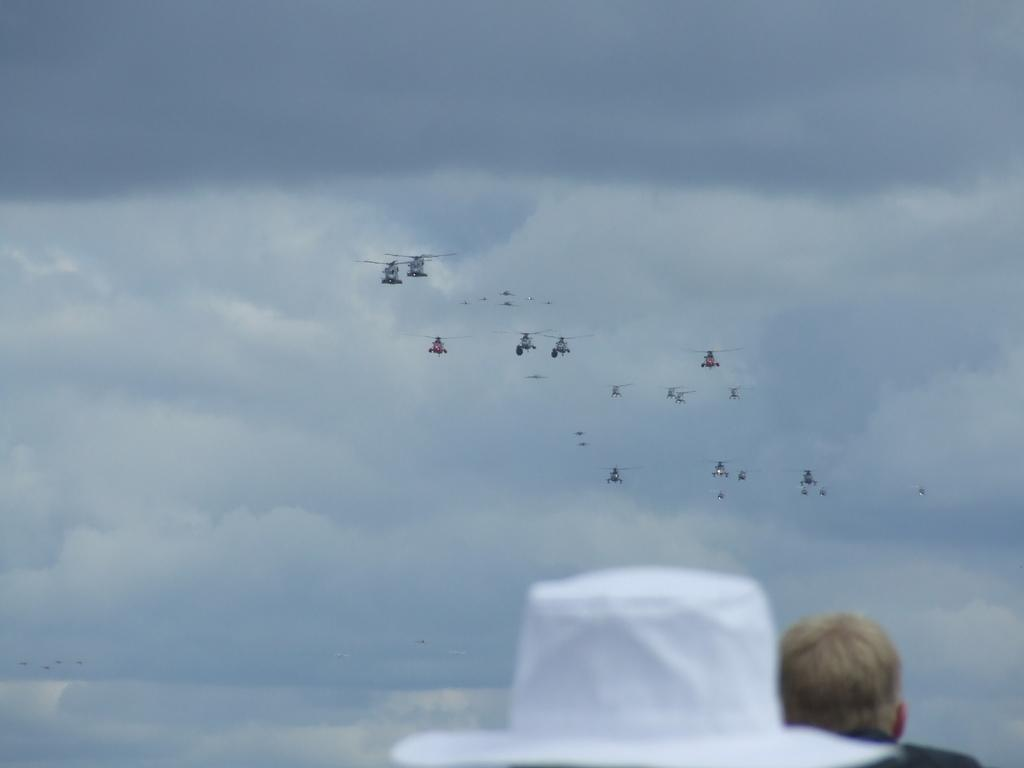What type of headwear is visible in the image? There is a white hat in the image. Can you describe the other person in the image? There is another person in the image, but their specific features are not mentioned in the facts. What is visible in the sky in the image? Clouds are present in the sky, which is visible in the background of the image. What is the context of the image, considering the presence of flights? The presence of flights suggests that the image might be related to air travel or an airport setting. What type of corn is being used to level the ground in the image? There is no corn or indication of leveling the ground present in the image. Is there an umbrella visible in the image? No, there is no umbrella visible in the image. 